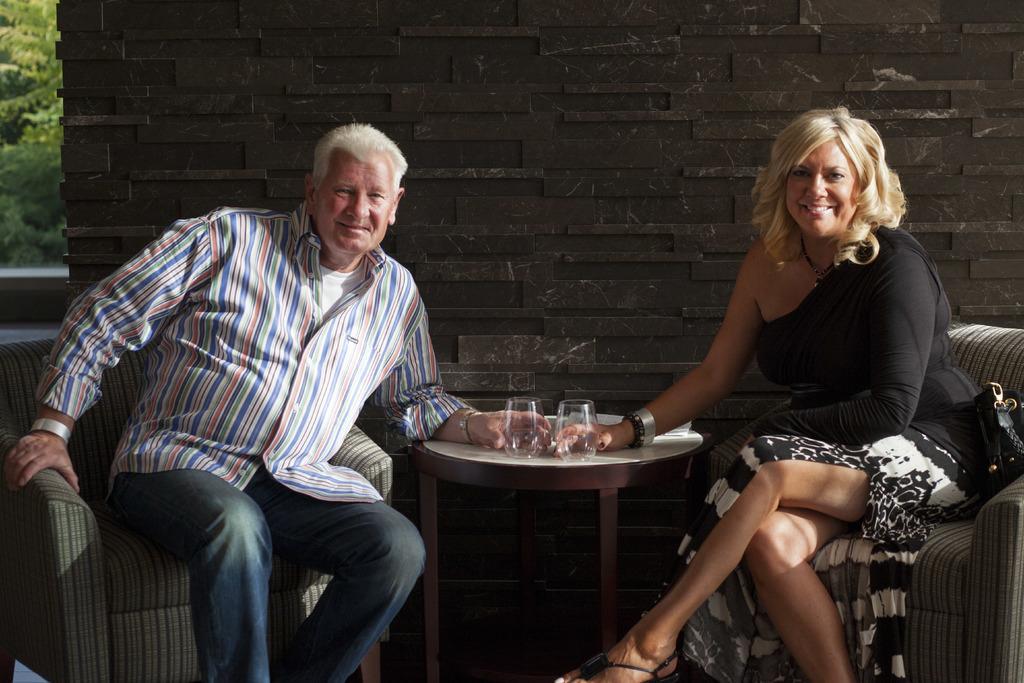Describe this image in one or two sentences. There are sitting on a chairs. They are smiling. They are holding a glass. They are wearing a watch. There is a table. There is a glass on a table. We can see in background wall and tree. 